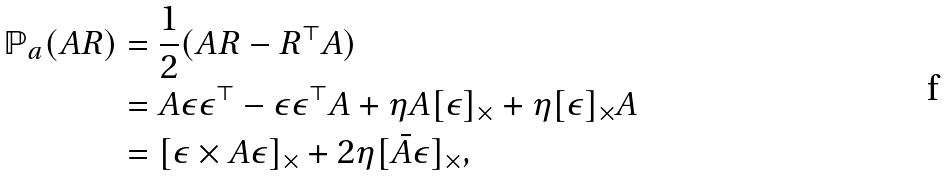<formula> <loc_0><loc_0><loc_500><loc_500>\mathbb { P } _ { a } ( A R ) & = \frac { 1 } { 2 } ( A R - R ^ { \top } A ) \\ & = A \epsilon \epsilon ^ { \top } - \epsilon \epsilon ^ { \top } A + \eta A [ \epsilon ] _ { \times } + \eta [ \epsilon ] _ { \times } A \\ & = [ \epsilon \times A \epsilon ] _ { \times } + 2 \eta [ \bar { A } \epsilon ] _ { \times } ,</formula> 